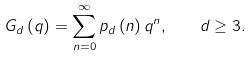Convert formula to latex. <formula><loc_0><loc_0><loc_500><loc_500>G _ { d } \left ( q \right ) = \sum _ { n = 0 } ^ { \infty } p _ { d } \left ( n \right ) q ^ { n } , \quad d \geq 3 .</formula> 